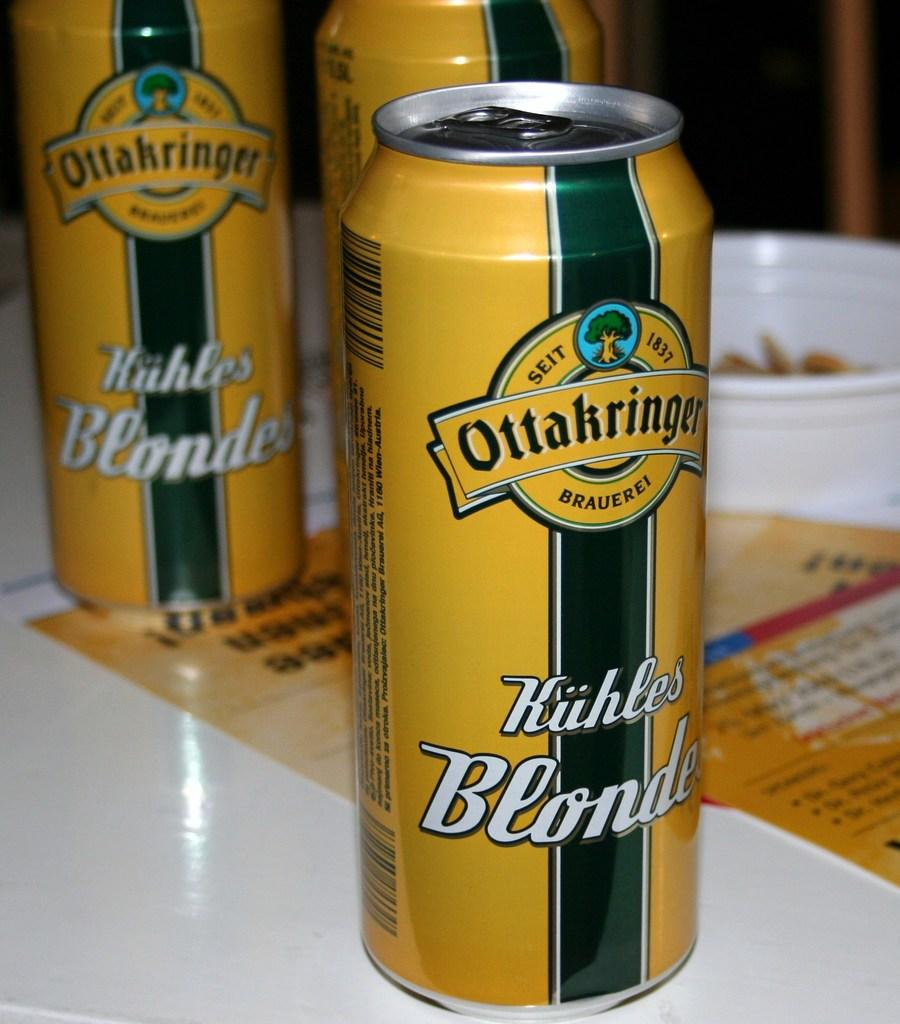<image>
Share a concise interpretation of the image provided. Some cans of drink with the word Ottakringer prominent. 